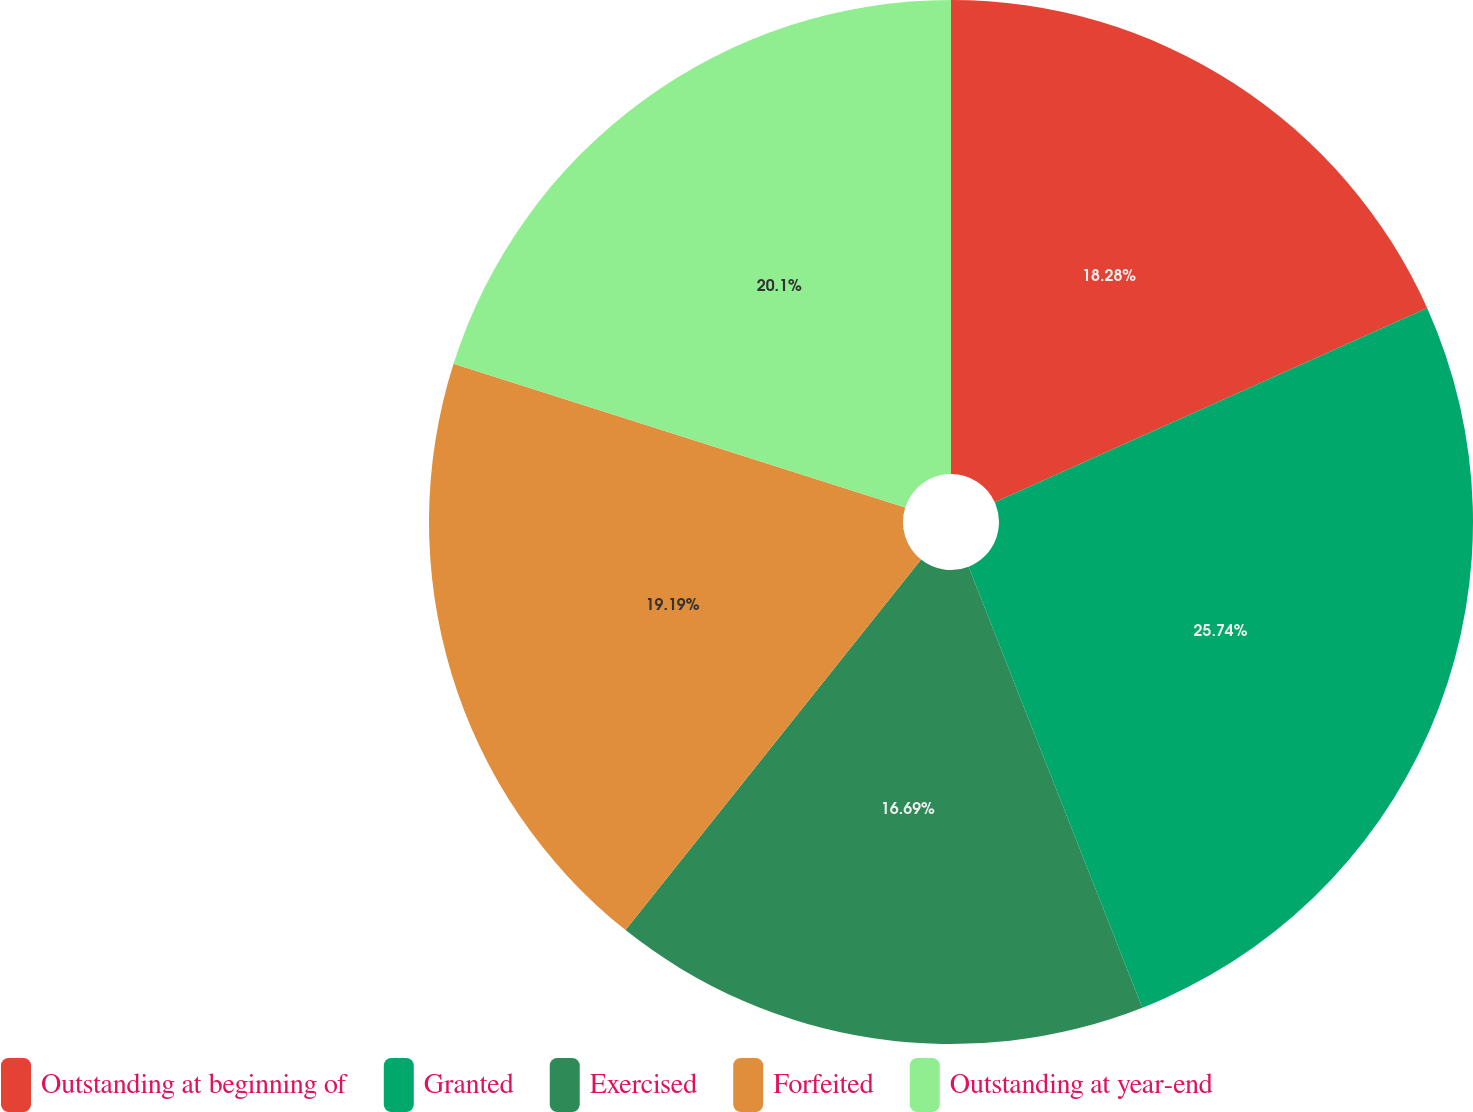Convert chart to OTSL. <chart><loc_0><loc_0><loc_500><loc_500><pie_chart><fcel>Outstanding at beginning of<fcel>Granted<fcel>Exercised<fcel>Forfeited<fcel>Outstanding at year-end<nl><fcel>18.28%<fcel>25.75%<fcel>16.69%<fcel>19.19%<fcel>20.1%<nl></chart> 